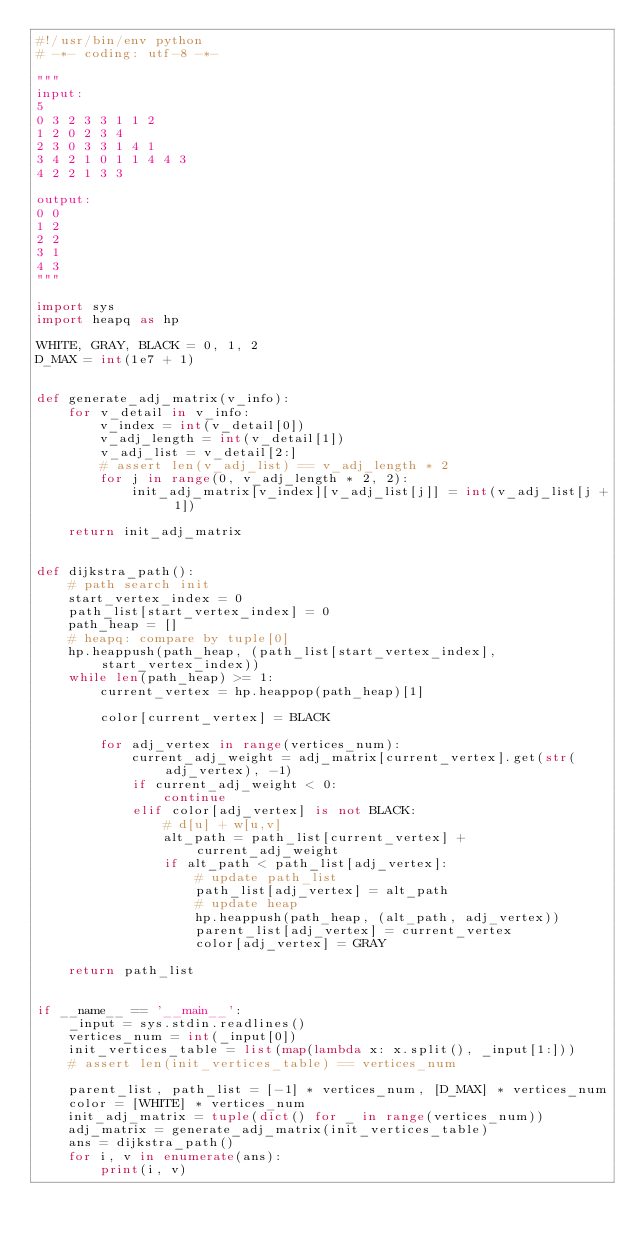Convert code to text. <code><loc_0><loc_0><loc_500><loc_500><_Python_>#!/usr/bin/env python
# -*- coding: utf-8 -*-

"""
input:
5
0 3 2 3 3 1 1 2
1 2 0 2 3 4
2 3 0 3 3 1 4 1
3 4 2 1 0 1 1 4 4 3
4 2 2 1 3 3

output:
0 0
1 2
2 2
3 1
4 3
"""

import sys
import heapq as hp

WHITE, GRAY, BLACK = 0, 1, 2
D_MAX = int(1e7 + 1)


def generate_adj_matrix(v_info):
    for v_detail in v_info:
        v_index = int(v_detail[0])
        v_adj_length = int(v_detail[1])
        v_adj_list = v_detail[2:]
        # assert len(v_adj_list) == v_adj_length * 2
        for j in range(0, v_adj_length * 2, 2):
            init_adj_matrix[v_index][v_adj_list[j]] = int(v_adj_list[j + 1])

    return init_adj_matrix


def dijkstra_path():
    # path search init
    start_vertex_index = 0
    path_list[start_vertex_index] = 0
    path_heap = []
    # heapq: compare by tuple[0]
    hp.heappush(path_heap, (path_list[start_vertex_index], start_vertex_index))
    while len(path_heap) >= 1:
        current_vertex = hp.heappop(path_heap)[1]

        color[current_vertex] = BLACK

        for adj_vertex in range(vertices_num):
            current_adj_weight = adj_matrix[current_vertex].get(str(adj_vertex), -1)
            if current_adj_weight < 0:
                continue
            elif color[adj_vertex] is not BLACK:
                # d[u] + w[u,v]
                alt_path = path_list[current_vertex] + current_adj_weight
                if alt_path < path_list[adj_vertex]:
                    # update path_list
                    path_list[adj_vertex] = alt_path
                    # update heap
                    hp.heappush(path_heap, (alt_path, adj_vertex))
                    parent_list[adj_vertex] = current_vertex
                    color[adj_vertex] = GRAY

    return path_list


if __name__ == '__main__':
    _input = sys.stdin.readlines()
    vertices_num = int(_input[0])
    init_vertices_table = list(map(lambda x: x.split(), _input[1:]))
    # assert len(init_vertices_table) == vertices_num

    parent_list, path_list = [-1] * vertices_num, [D_MAX] * vertices_num
    color = [WHITE] * vertices_num
    init_adj_matrix = tuple(dict() for _ in range(vertices_num))
    adj_matrix = generate_adj_matrix(init_vertices_table)
    ans = dijkstra_path()
    for i, v in enumerate(ans):
        print(i, v)</code> 